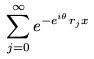<formula> <loc_0><loc_0><loc_500><loc_500>\sum _ { j = 0 } ^ { \infty } e ^ { - e ^ { i \theta } r _ { j } x }</formula> 